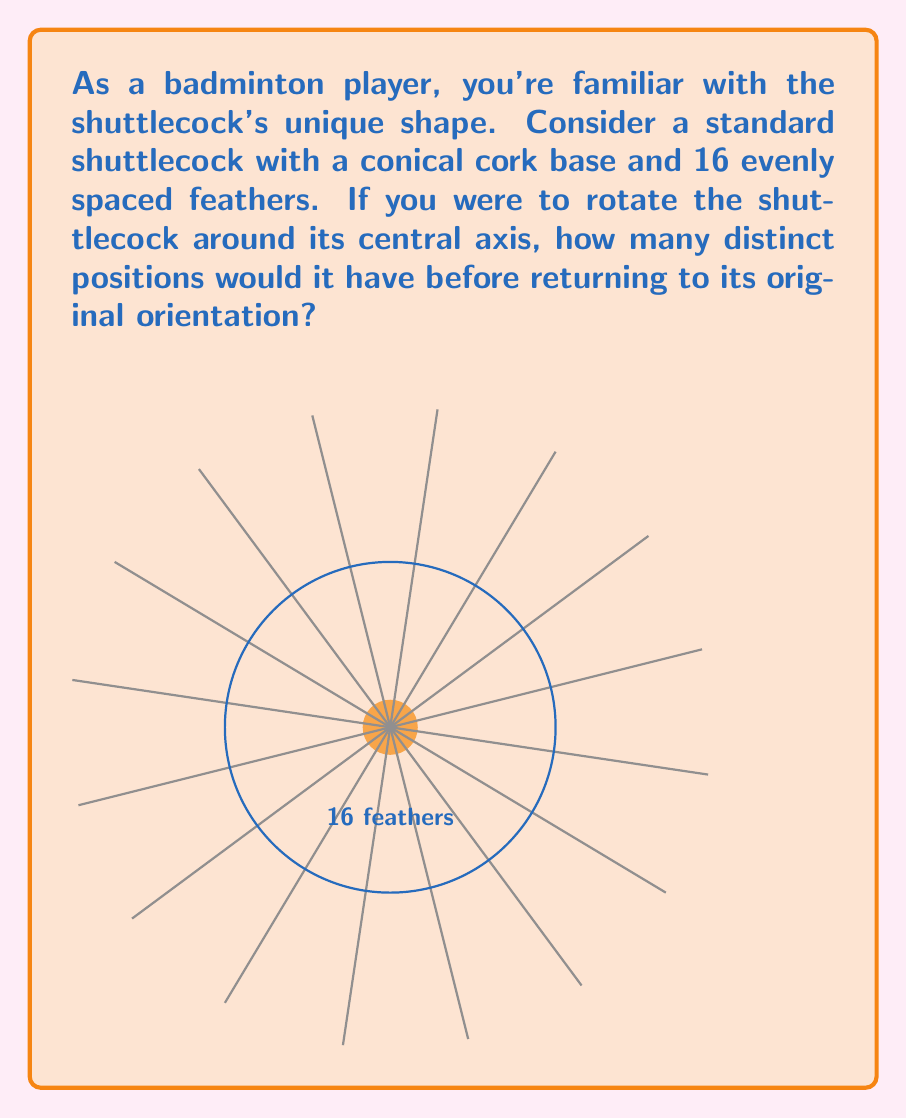Can you solve this math problem? To determine the order of rotational symmetry for a shuttlecock, we need to follow these steps:

1) First, we need to understand what rotational symmetry means. An object has rotational symmetry if it looks the same after a certain amount of rotation.

2) For a shuttlecock, we need to consider its key features:
   - It has a circular base (the cork)
   - It has 16 evenly spaced feathers

3) The shuttlecock will look the same after rotating by a certain angle. This angle is given by:

   $$\text{Angle of rotation} = \frac{360°}{\text{Number of feathers}}$$

4) In this case:
   $$\text{Angle of rotation} = \frac{360°}{16} = 22.5°$$

5) This means that the shuttlecock will look the same after every 22.5° rotation.

6) The order of rotational symmetry is the number of distinct positions the shuttlecock can have before returning to its original position. This is equal to the number of feathers.

7) Therefore, the order of rotational symmetry for a standard shuttlecock with 16 feathers is 16.

This means that if you rotate the shuttlecock 16 times by 22.5°, it will complete a full 360° rotation and return to its original position.
Answer: 16 